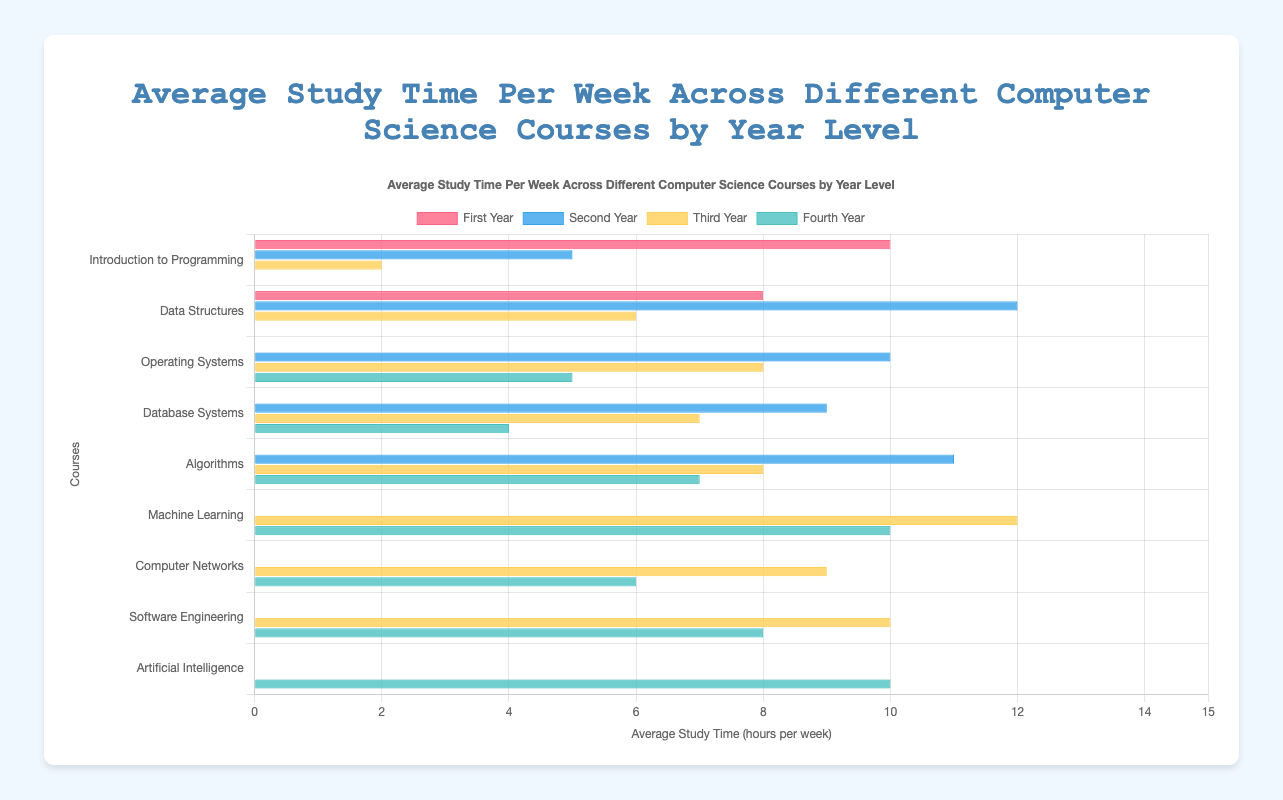Which course requires the least average study time in the Third Year? Look at the horizontal bars for the Third Year and identify the shortest one. The shortest bar is "Introduction to Programming" with 2 hours per week.
Answer: Introduction to Programming Which course has the highest average study time in the Second Year? Examine the horizontal bars for the Second Year and find the longest one. The longest bar is "Data Structures" with 12 hours per week.
Answer: Data Structures How does the average study time for "Machine Learning" compare between the Third Year and the Fourth Year? Compare the lengths of the bars for "Machine Learning" in the Third Year and the Fourth Year. The Third Year has 12 hours and the Fourth Year has 10 hours, so the Third Year has 2 more hours per week.
Answer: Third Year is 2 hours more What is the total average study time for "Operating Systems" across all year levels? Add the average study time for "Operating Systems" in the Second Year (10), Third Year (8), and Fourth Year (5). The total is 10 + 8 + 5 = 23 hours.
Answer: 23 hours Which year level has the highest average study time for "Algorithms"? Check the bars for "Algorithms" across different years and identify the longest one. The longest bar is in the Second Year with 11 hours per week.
Answer: Second Year What is the difference in average study time for "Database Systems" between the Second Year and the Fourth Year? Subtract the average study time in the Fourth Year (4 hours) from that in the Second Year (9 hours). The difference is 9 - 4 = 5 hours.
Answer: 5 hours How many more hours per week do "First Year" students spend on "Introduction to Programming" compared to "Third Year" students? Compare the average study time for "Introduction to Programming" in the First Year (10 hours) and the Third Year (2 hours). The difference is 10 - 2 = 8 hours.
Answer: 8 hours Which course has a consistent average study time across different year levels? Look for a course where the horizontal bars are almost equal in length across all year levels. "Artificial Intelligence" has 10 hours in the Fourth Year, which is fairly consistent.
Answer: Artificial Intelligence What is the average study time for "Computer Networks" across the Third and Fourth Years? Add the average study times for "Computer Networks" in the Third Year (9 hours) and Fourth Year (6 hours) and divide by 2. The average is (9 + 6) / 2 = 7.5 hours.
Answer: 7.5 hours 